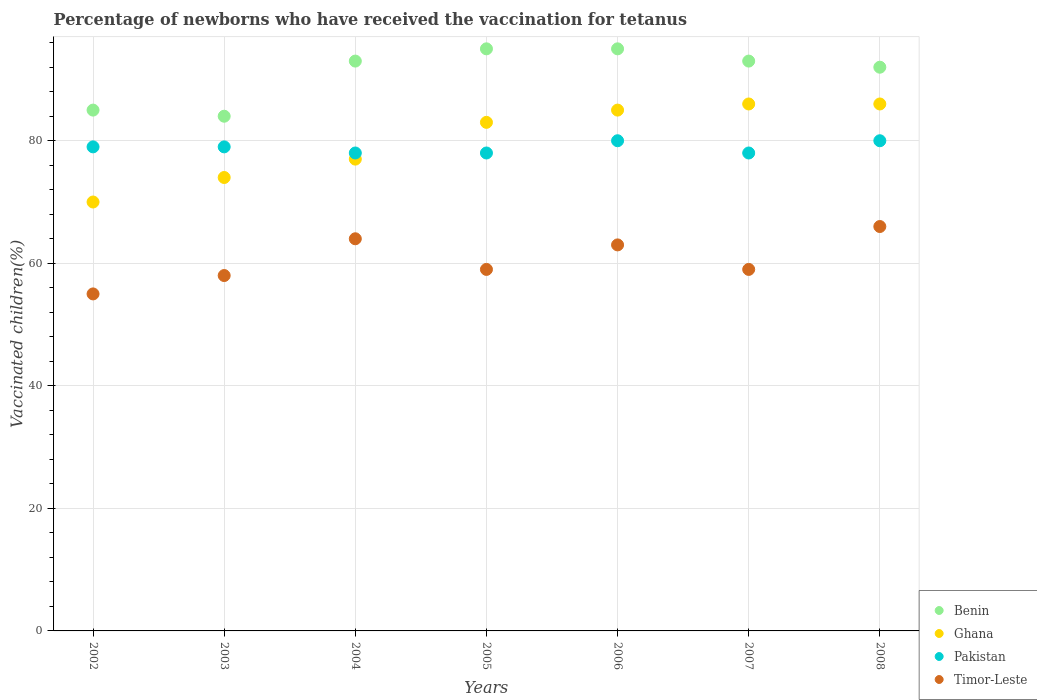How many different coloured dotlines are there?
Your answer should be very brief. 4. In which year was the percentage of vaccinated children in Timor-Leste maximum?
Provide a short and direct response. 2008. In which year was the percentage of vaccinated children in Benin minimum?
Keep it short and to the point. 2003. What is the total percentage of vaccinated children in Pakistan in the graph?
Provide a succinct answer. 552. What is the difference between the percentage of vaccinated children in Ghana in 2004 and that in 2006?
Ensure brevity in your answer.  -8. What is the difference between the percentage of vaccinated children in Timor-Leste in 2002 and the percentage of vaccinated children in Pakistan in 2007?
Your answer should be compact. -23. What is the average percentage of vaccinated children in Timor-Leste per year?
Ensure brevity in your answer.  60.57. In the year 2004, what is the difference between the percentage of vaccinated children in Benin and percentage of vaccinated children in Ghana?
Provide a succinct answer. 16. What is the ratio of the percentage of vaccinated children in Benin in 2002 to that in 2008?
Provide a succinct answer. 0.92. Is the difference between the percentage of vaccinated children in Benin in 2004 and 2007 greater than the difference between the percentage of vaccinated children in Ghana in 2004 and 2007?
Your answer should be compact. Yes. What is the difference between the highest and the lowest percentage of vaccinated children in Timor-Leste?
Ensure brevity in your answer.  11. Is the sum of the percentage of vaccinated children in Timor-Leste in 2002 and 2005 greater than the maximum percentage of vaccinated children in Benin across all years?
Your answer should be very brief. Yes. Is it the case that in every year, the sum of the percentage of vaccinated children in Benin and percentage of vaccinated children in Timor-Leste  is greater than the percentage of vaccinated children in Pakistan?
Provide a succinct answer. Yes. How many dotlines are there?
Your answer should be very brief. 4. What is the difference between two consecutive major ticks on the Y-axis?
Your response must be concise. 20. Where does the legend appear in the graph?
Provide a short and direct response. Bottom right. How many legend labels are there?
Ensure brevity in your answer.  4. How are the legend labels stacked?
Provide a succinct answer. Vertical. What is the title of the graph?
Your answer should be very brief. Percentage of newborns who have received the vaccination for tetanus. What is the label or title of the Y-axis?
Provide a short and direct response. Vaccinated children(%). What is the Vaccinated children(%) in Ghana in 2002?
Provide a succinct answer. 70. What is the Vaccinated children(%) of Pakistan in 2002?
Offer a terse response. 79. What is the Vaccinated children(%) in Benin in 2003?
Make the answer very short. 84. What is the Vaccinated children(%) of Ghana in 2003?
Make the answer very short. 74. What is the Vaccinated children(%) of Pakistan in 2003?
Offer a terse response. 79. What is the Vaccinated children(%) in Benin in 2004?
Provide a short and direct response. 93. What is the Vaccinated children(%) in Timor-Leste in 2004?
Your answer should be compact. 64. What is the Vaccinated children(%) in Pakistan in 2006?
Provide a succinct answer. 80. What is the Vaccinated children(%) of Benin in 2007?
Keep it short and to the point. 93. What is the Vaccinated children(%) of Pakistan in 2007?
Offer a very short reply. 78. What is the Vaccinated children(%) in Timor-Leste in 2007?
Make the answer very short. 59. What is the Vaccinated children(%) in Benin in 2008?
Your response must be concise. 92. Across all years, what is the maximum Vaccinated children(%) of Benin?
Give a very brief answer. 95. Across all years, what is the maximum Vaccinated children(%) of Ghana?
Offer a very short reply. 86. Across all years, what is the maximum Vaccinated children(%) in Timor-Leste?
Make the answer very short. 66. Across all years, what is the minimum Vaccinated children(%) of Timor-Leste?
Your answer should be compact. 55. What is the total Vaccinated children(%) in Benin in the graph?
Keep it short and to the point. 637. What is the total Vaccinated children(%) of Ghana in the graph?
Your answer should be very brief. 561. What is the total Vaccinated children(%) of Pakistan in the graph?
Offer a very short reply. 552. What is the total Vaccinated children(%) of Timor-Leste in the graph?
Provide a succinct answer. 424. What is the difference between the Vaccinated children(%) of Ghana in 2002 and that in 2003?
Ensure brevity in your answer.  -4. What is the difference between the Vaccinated children(%) in Pakistan in 2002 and that in 2003?
Your response must be concise. 0. What is the difference between the Vaccinated children(%) of Timor-Leste in 2002 and that in 2003?
Keep it short and to the point. -3. What is the difference between the Vaccinated children(%) of Benin in 2002 and that in 2004?
Your response must be concise. -8. What is the difference between the Vaccinated children(%) in Ghana in 2002 and that in 2004?
Offer a terse response. -7. What is the difference between the Vaccinated children(%) in Pakistan in 2002 and that in 2004?
Offer a very short reply. 1. What is the difference between the Vaccinated children(%) in Ghana in 2002 and that in 2005?
Your answer should be compact. -13. What is the difference between the Vaccinated children(%) in Pakistan in 2002 and that in 2005?
Ensure brevity in your answer.  1. What is the difference between the Vaccinated children(%) in Timor-Leste in 2002 and that in 2005?
Offer a terse response. -4. What is the difference between the Vaccinated children(%) of Benin in 2002 and that in 2006?
Your answer should be compact. -10. What is the difference between the Vaccinated children(%) of Ghana in 2002 and that in 2006?
Provide a short and direct response. -15. What is the difference between the Vaccinated children(%) of Pakistan in 2002 and that in 2006?
Provide a short and direct response. -1. What is the difference between the Vaccinated children(%) in Timor-Leste in 2002 and that in 2006?
Provide a succinct answer. -8. What is the difference between the Vaccinated children(%) of Ghana in 2002 and that in 2007?
Provide a succinct answer. -16. What is the difference between the Vaccinated children(%) of Pakistan in 2002 and that in 2007?
Give a very brief answer. 1. What is the difference between the Vaccinated children(%) of Timor-Leste in 2002 and that in 2007?
Ensure brevity in your answer.  -4. What is the difference between the Vaccinated children(%) in Pakistan in 2002 and that in 2008?
Your answer should be compact. -1. What is the difference between the Vaccinated children(%) in Timor-Leste in 2003 and that in 2005?
Offer a very short reply. -1. What is the difference between the Vaccinated children(%) in Ghana in 2003 and that in 2006?
Make the answer very short. -11. What is the difference between the Vaccinated children(%) in Pakistan in 2003 and that in 2006?
Provide a succinct answer. -1. What is the difference between the Vaccinated children(%) of Benin in 2003 and that in 2007?
Offer a very short reply. -9. What is the difference between the Vaccinated children(%) in Ghana in 2003 and that in 2007?
Make the answer very short. -12. What is the difference between the Vaccinated children(%) in Pakistan in 2003 and that in 2007?
Your answer should be compact. 1. What is the difference between the Vaccinated children(%) of Timor-Leste in 2003 and that in 2007?
Ensure brevity in your answer.  -1. What is the difference between the Vaccinated children(%) of Pakistan in 2003 and that in 2008?
Keep it short and to the point. -1. What is the difference between the Vaccinated children(%) in Ghana in 2004 and that in 2005?
Your answer should be very brief. -6. What is the difference between the Vaccinated children(%) of Ghana in 2004 and that in 2006?
Give a very brief answer. -8. What is the difference between the Vaccinated children(%) of Timor-Leste in 2004 and that in 2006?
Offer a very short reply. 1. What is the difference between the Vaccinated children(%) of Benin in 2004 and that in 2007?
Your response must be concise. 0. What is the difference between the Vaccinated children(%) in Pakistan in 2004 and that in 2007?
Offer a terse response. 0. What is the difference between the Vaccinated children(%) of Timor-Leste in 2004 and that in 2007?
Provide a short and direct response. 5. What is the difference between the Vaccinated children(%) of Benin in 2004 and that in 2008?
Your answer should be compact. 1. What is the difference between the Vaccinated children(%) of Pakistan in 2004 and that in 2008?
Provide a short and direct response. -2. What is the difference between the Vaccinated children(%) in Timor-Leste in 2004 and that in 2008?
Provide a short and direct response. -2. What is the difference between the Vaccinated children(%) of Benin in 2005 and that in 2006?
Offer a terse response. 0. What is the difference between the Vaccinated children(%) in Pakistan in 2005 and that in 2006?
Your answer should be compact. -2. What is the difference between the Vaccinated children(%) of Benin in 2005 and that in 2007?
Keep it short and to the point. 2. What is the difference between the Vaccinated children(%) in Ghana in 2005 and that in 2007?
Provide a short and direct response. -3. What is the difference between the Vaccinated children(%) of Pakistan in 2005 and that in 2007?
Keep it short and to the point. 0. What is the difference between the Vaccinated children(%) in Timor-Leste in 2005 and that in 2007?
Your answer should be compact. 0. What is the difference between the Vaccinated children(%) of Timor-Leste in 2005 and that in 2008?
Provide a short and direct response. -7. What is the difference between the Vaccinated children(%) of Benin in 2006 and that in 2007?
Your response must be concise. 2. What is the difference between the Vaccinated children(%) in Pakistan in 2006 and that in 2007?
Offer a very short reply. 2. What is the difference between the Vaccinated children(%) in Timor-Leste in 2006 and that in 2007?
Keep it short and to the point. 4. What is the difference between the Vaccinated children(%) in Benin in 2006 and that in 2008?
Your answer should be very brief. 3. What is the difference between the Vaccinated children(%) of Ghana in 2006 and that in 2008?
Your answer should be compact. -1. What is the difference between the Vaccinated children(%) of Timor-Leste in 2007 and that in 2008?
Give a very brief answer. -7. What is the difference between the Vaccinated children(%) in Benin in 2002 and the Vaccinated children(%) in Pakistan in 2003?
Your answer should be very brief. 6. What is the difference between the Vaccinated children(%) in Ghana in 2002 and the Vaccinated children(%) in Pakistan in 2003?
Your response must be concise. -9. What is the difference between the Vaccinated children(%) in Pakistan in 2002 and the Vaccinated children(%) in Timor-Leste in 2003?
Give a very brief answer. 21. What is the difference between the Vaccinated children(%) of Benin in 2002 and the Vaccinated children(%) of Pakistan in 2004?
Your answer should be very brief. 7. What is the difference between the Vaccinated children(%) in Benin in 2002 and the Vaccinated children(%) in Timor-Leste in 2004?
Your response must be concise. 21. What is the difference between the Vaccinated children(%) of Ghana in 2002 and the Vaccinated children(%) of Timor-Leste in 2004?
Your answer should be compact. 6. What is the difference between the Vaccinated children(%) in Pakistan in 2002 and the Vaccinated children(%) in Timor-Leste in 2004?
Make the answer very short. 15. What is the difference between the Vaccinated children(%) of Benin in 2002 and the Vaccinated children(%) of Ghana in 2005?
Your response must be concise. 2. What is the difference between the Vaccinated children(%) of Ghana in 2002 and the Vaccinated children(%) of Pakistan in 2005?
Make the answer very short. -8. What is the difference between the Vaccinated children(%) of Ghana in 2002 and the Vaccinated children(%) of Timor-Leste in 2005?
Provide a succinct answer. 11. What is the difference between the Vaccinated children(%) of Benin in 2002 and the Vaccinated children(%) of Ghana in 2006?
Ensure brevity in your answer.  0. What is the difference between the Vaccinated children(%) in Benin in 2002 and the Vaccinated children(%) in Pakistan in 2006?
Offer a terse response. 5. What is the difference between the Vaccinated children(%) in Benin in 2002 and the Vaccinated children(%) in Timor-Leste in 2006?
Your answer should be very brief. 22. What is the difference between the Vaccinated children(%) of Ghana in 2002 and the Vaccinated children(%) of Timor-Leste in 2006?
Your response must be concise. 7. What is the difference between the Vaccinated children(%) in Benin in 2002 and the Vaccinated children(%) in Pakistan in 2007?
Give a very brief answer. 7. What is the difference between the Vaccinated children(%) in Benin in 2002 and the Vaccinated children(%) in Timor-Leste in 2007?
Provide a short and direct response. 26. What is the difference between the Vaccinated children(%) of Ghana in 2002 and the Vaccinated children(%) of Pakistan in 2007?
Provide a succinct answer. -8. What is the difference between the Vaccinated children(%) in Ghana in 2002 and the Vaccinated children(%) in Timor-Leste in 2007?
Make the answer very short. 11. What is the difference between the Vaccinated children(%) of Pakistan in 2002 and the Vaccinated children(%) of Timor-Leste in 2007?
Keep it short and to the point. 20. What is the difference between the Vaccinated children(%) of Benin in 2002 and the Vaccinated children(%) of Ghana in 2008?
Your response must be concise. -1. What is the difference between the Vaccinated children(%) of Benin in 2002 and the Vaccinated children(%) of Pakistan in 2008?
Ensure brevity in your answer.  5. What is the difference between the Vaccinated children(%) of Pakistan in 2002 and the Vaccinated children(%) of Timor-Leste in 2008?
Provide a short and direct response. 13. What is the difference between the Vaccinated children(%) of Benin in 2003 and the Vaccinated children(%) of Timor-Leste in 2004?
Your response must be concise. 20. What is the difference between the Vaccinated children(%) in Benin in 2003 and the Vaccinated children(%) in Pakistan in 2005?
Offer a very short reply. 6. What is the difference between the Vaccinated children(%) in Benin in 2003 and the Vaccinated children(%) in Timor-Leste in 2005?
Offer a terse response. 25. What is the difference between the Vaccinated children(%) of Ghana in 2003 and the Vaccinated children(%) of Pakistan in 2005?
Your answer should be very brief. -4. What is the difference between the Vaccinated children(%) in Ghana in 2003 and the Vaccinated children(%) in Timor-Leste in 2005?
Make the answer very short. 15. What is the difference between the Vaccinated children(%) of Pakistan in 2003 and the Vaccinated children(%) of Timor-Leste in 2005?
Offer a very short reply. 20. What is the difference between the Vaccinated children(%) in Ghana in 2003 and the Vaccinated children(%) in Timor-Leste in 2006?
Make the answer very short. 11. What is the difference between the Vaccinated children(%) of Benin in 2003 and the Vaccinated children(%) of Ghana in 2007?
Your response must be concise. -2. What is the difference between the Vaccinated children(%) of Ghana in 2003 and the Vaccinated children(%) of Pakistan in 2007?
Provide a short and direct response. -4. What is the difference between the Vaccinated children(%) in Pakistan in 2003 and the Vaccinated children(%) in Timor-Leste in 2007?
Ensure brevity in your answer.  20. What is the difference between the Vaccinated children(%) in Benin in 2003 and the Vaccinated children(%) in Timor-Leste in 2008?
Make the answer very short. 18. What is the difference between the Vaccinated children(%) in Ghana in 2003 and the Vaccinated children(%) in Pakistan in 2008?
Provide a succinct answer. -6. What is the difference between the Vaccinated children(%) of Ghana in 2003 and the Vaccinated children(%) of Timor-Leste in 2008?
Your response must be concise. 8. What is the difference between the Vaccinated children(%) in Benin in 2004 and the Vaccinated children(%) in Pakistan in 2005?
Provide a succinct answer. 15. What is the difference between the Vaccinated children(%) in Benin in 2004 and the Vaccinated children(%) in Timor-Leste in 2005?
Keep it short and to the point. 34. What is the difference between the Vaccinated children(%) in Pakistan in 2004 and the Vaccinated children(%) in Timor-Leste in 2005?
Make the answer very short. 19. What is the difference between the Vaccinated children(%) in Benin in 2004 and the Vaccinated children(%) in Ghana in 2006?
Keep it short and to the point. 8. What is the difference between the Vaccinated children(%) in Benin in 2004 and the Vaccinated children(%) in Pakistan in 2006?
Ensure brevity in your answer.  13. What is the difference between the Vaccinated children(%) in Ghana in 2004 and the Vaccinated children(%) in Timor-Leste in 2006?
Provide a short and direct response. 14. What is the difference between the Vaccinated children(%) of Benin in 2004 and the Vaccinated children(%) of Ghana in 2007?
Ensure brevity in your answer.  7. What is the difference between the Vaccinated children(%) in Benin in 2004 and the Vaccinated children(%) in Pakistan in 2007?
Give a very brief answer. 15. What is the difference between the Vaccinated children(%) of Ghana in 2004 and the Vaccinated children(%) of Pakistan in 2007?
Provide a succinct answer. -1. What is the difference between the Vaccinated children(%) in Ghana in 2004 and the Vaccinated children(%) in Timor-Leste in 2007?
Offer a very short reply. 18. What is the difference between the Vaccinated children(%) in Benin in 2004 and the Vaccinated children(%) in Ghana in 2008?
Offer a very short reply. 7. What is the difference between the Vaccinated children(%) of Benin in 2004 and the Vaccinated children(%) of Pakistan in 2008?
Make the answer very short. 13. What is the difference between the Vaccinated children(%) in Benin in 2004 and the Vaccinated children(%) in Timor-Leste in 2008?
Give a very brief answer. 27. What is the difference between the Vaccinated children(%) of Ghana in 2004 and the Vaccinated children(%) of Pakistan in 2008?
Your response must be concise. -3. What is the difference between the Vaccinated children(%) in Benin in 2005 and the Vaccinated children(%) in Ghana in 2006?
Offer a terse response. 10. What is the difference between the Vaccinated children(%) of Benin in 2005 and the Vaccinated children(%) of Pakistan in 2006?
Your response must be concise. 15. What is the difference between the Vaccinated children(%) of Ghana in 2005 and the Vaccinated children(%) of Timor-Leste in 2006?
Your response must be concise. 20. What is the difference between the Vaccinated children(%) in Pakistan in 2005 and the Vaccinated children(%) in Timor-Leste in 2006?
Make the answer very short. 15. What is the difference between the Vaccinated children(%) of Benin in 2005 and the Vaccinated children(%) of Pakistan in 2007?
Keep it short and to the point. 17. What is the difference between the Vaccinated children(%) of Benin in 2005 and the Vaccinated children(%) of Timor-Leste in 2007?
Make the answer very short. 36. What is the difference between the Vaccinated children(%) in Pakistan in 2005 and the Vaccinated children(%) in Timor-Leste in 2007?
Your answer should be very brief. 19. What is the difference between the Vaccinated children(%) of Benin in 2005 and the Vaccinated children(%) of Ghana in 2008?
Offer a very short reply. 9. What is the difference between the Vaccinated children(%) of Benin in 2005 and the Vaccinated children(%) of Pakistan in 2008?
Your response must be concise. 15. What is the difference between the Vaccinated children(%) in Benin in 2005 and the Vaccinated children(%) in Timor-Leste in 2008?
Offer a very short reply. 29. What is the difference between the Vaccinated children(%) in Ghana in 2005 and the Vaccinated children(%) in Pakistan in 2008?
Your answer should be very brief. 3. What is the difference between the Vaccinated children(%) in Ghana in 2005 and the Vaccinated children(%) in Timor-Leste in 2008?
Your answer should be very brief. 17. What is the difference between the Vaccinated children(%) in Benin in 2006 and the Vaccinated children(%) in Ghana in 2007?
Provide a succinct answer. 9. What is the difference between the Vaccinated children(%) in Benin in 2006 and the Vaccinated children(%) in Pakistan in 2007?
Ensure brevity in your answer.  17. What is the difference between the Vaccinated children(%) in Pakistan in 2006 and the Vaccinated children(%) in Timor-Leste in 2007?
Offer a terse response. 21. What is the difference between the Vaccinated children(%) of Benin in 2006 and the Vaccinated children(%) of Timor-Leste in 2008?
Provide a short and direct response. 29. What is the difference between the Vaccinated children(%) in Ghana in 2006 and the Vaccinated children(%) in Timor-Leste in 2008?
Your answer should be very brief. 19. What is the difference between the Vaccinated children(%) of Pakistan in 2006 and the Vaccinated children(%) of Timor-Leste in 2008?
Make the answer very short. 14. What is the difference between the Vaccinated children(%) of Benin in 2007 and the Vaccinated children(%) of Ghana in 2008?
Make the answer very short. 7. What is the difference between the Vaccinated children(%) in Benin in 2007 and the Vaccinated children(%) in Pakistan in 2008?
Give a very brief answer. 13. What is the difference between the Vaccinated children(%) of Benin in 2007 and the Vaccinated children(%) of Timor-Leste in 2008?
Ensure brevity in your answer.  27. What is the difference between the Vaccinated children(%) of Ghana in 2007 and the Vaccinated children(%) of Pakistan in 2008?
Ensure brevity in your answer.  6. What is the difference between the Vaccinated children(%) in Pakistan in 2007 and the Vaccinated children(%) in Timor-Leste in 2008?
Offer a very short reply. 12. What is the average Vaccinated children(%) in Benin per year?
Keep it short and to the point. 91. What is the average Vaccinated children(%) in Ghana per year?
Provide a succinct answer. 80.14. What is the average Vaccinated children(%) in Pakistan per year?
Ensure brevity in your answer.  78.86. What is the average Vaccinated children(%) of Timor-Leste per year?
Make the answer very short. 60.57. In the year 2002, what is the difference between the Vaccinated children(%) of Ghana and Vaccinated children(%) of Timor-Leste?
Your answer should be very brief. 15. In the year 2002, what is the difference between the Vaccinated children(%) of Pakistan and Vaccinated children(%) of Timor-Leste?
Make the answer very short. 24. In the year 2004, what is the difference between the Vaccinated children(%) of Ghana and Vaccinated children(%) of Pakistan?
Your answer should be very brief. -1. In the year 2004, what is the difference between the Vaccinated children(%) of Ghana and Vaccinated children(%) of Timor-Leste?
Give a very brief answer. 13. In the year 2005, what is the difference between the Vaccinated children(%) of Benin and Vaccinated children(%) of Ghana?
Provide a succinct answer. 12. In the year 2005, what is the difference between the Vaccinated children(%) in Ghana and Vaccinated children(%) in Pakistan?
Provide a succinct answer. 5. In the year 2005, what is the difference between the Vaccinated children(%) in Ghana and Vaccinated children(%) in Timor-Leste?
Your answer should be compact. 24. In the year 2005, what is the difference between the Vaccinated children(%) in Pakistan and Vaccinated children(%) in Timor-Leste?
Ensure brevity in your answer.  19. In the year 2006, what is the difference between the Vaccinated children(%) of Benin and Vaccinated children(%) of Ghana?
Your answer should be very brief. 10. In the year 2006, what is the difference between the Vaccinated children(%) of Benin and Vaccinated children(%) of Pakistan?
Give a very brief answer. 15. In the year 2006, what is the difference between the Vaccinated children(%) in Benin and Vaccinated children(%) in Timor-Leste?
Offer a terse response. 32. In the year 2006, what is the difference between the Vaccinated children(%) of Pakistan and Vaccinated children(%) of Timor-Leste?
Your answer should be compact. 17. In the year 2007, what is the difference between the Vaccinated children(%) of Benin and Vaccinated children(%) of Ghana?
Your answer should be compact. 7. In the year 2007, what is the difference between the Vaccinated children(%) in Benin and Vaccinated children(%) in Timor-Leste?
Your answer should be compact. 34. In the year 2007, what is the difference between the Vaccinated children(%) in Ghana and Vaccinated children(%) in Pakistan?
Your answer should be very brief. 8. In the year 2007, what is the difference between the Vaccinated children(%) in Ghana and Vaccinated children(%) in Timor-Leste?
Ensure brevity in your answer.  27. In the year 2008, what is the difference between the Vaccinated children(%) of Benin and Vaccinated children(%) of Ghana?
Provide a succinct answer. 6. In the year 2008, what is the difference between the Vaccinated children(%) of Ghana and Vaccinated children(%) of Pakistan?
Your answer should be very brief. 6. In the year 2008, what is the difference between the Vaccinated children(%) in Pakistan and Vaccinated children(%) in Timor-Leste?
Provide a succinct answer. 14. What is the ratio of the Vaccinated children(%) of Benin in 2002 to that in 2003?
Provide a short and direct response. 1.01. What is the ratio of the Vaccinated children(%) in Ghana in 2002 to that in 2003?
Your answer should be compact. 0.95. What is the ratio of the Vaccinated children(%) of Pakistan in 2002 to that in 2003?
Offer a terse response. 1. What is the ratio of the Vaccinated children(%) in Timor-Leste in 2002 to that in 2003?
Provide a succinct answer. 0.95. What is the ratio of the Vaccinated children(%) in Benin in 2002 to that in 2004?
Provide a succinct answer. 0.91. What is the ratio of the Vaccinated children(%) in Pakistan in 2002 to that in 2004?
Give a very brief answer. 1.01. What is the ratio of the Vaccinated children(%) of Timor-Leste in 2002 to that in 2004?
Your answer should be very brief. 0.86. What is the ratio of the Vaccinated children(%) in Benin in 2002 to that in 2005?
Your answer should be very brief. 0.89. What is the ratio of the Vaccinated children(%) in Ghana in 2002 to that in 2005?
Make the answer very short. 0.84. What is the ratio of the Vaccinated children(%) of Pakistan in 2002 to that in 2005?
Keep it short and to the point. 1.01. What is the ratio of the Vaccinated children(%) of Timor-Leste in 2002 to that in 2005?
Ensure brevity in your answer.  0.93. What is the ratio of the Vaccinated children(%) of Benin in 2002 to that in 2006?
Give a very brief answer. 0.89. What is the ratio of the Vaccinated children(%) in Ghana in 2002 to that in 2006?
Provide a short and direct response. 0.82. What is the ratio of the Vaccinated children(%) in Pakistan in 2002 to that in 2006?
Provide a short and direct response. 0.99. What is the ratio of the Vaccinated children(%) in Timor-Leste in 2002 to that in 2006?
Ensure brevity in your answer.  0.87. What is the ratio of the Vaccinated children(%) in Benin in 2002 to that in 2007?
Your answer should be very brief. 0.91. What is the ratio of the Vaccinated children(%) of Ghana in 2002 to that in 2007?
Your response must be concise. 0.81. What is the ratio of the Vaccinated children(%) in Pakistan in 2002 to that in 2007?
Provide a succinct answer. 1.01. What is the ratio of the Vaccinated children(%) in Timor-Leste in 2002 to that in 2007?
Your answer should be very brief. 0.93. What is the ratio of the Vaccinated children(%) in Benin in 2002 to that in 2008?
Give a very brief answer. 0.92. What is the ratio of the Vaccinated children(%) of Ghana in 2002 to that in 2008?
Offer a very short reply. 0.81. What is the ratio of the Vaccinated children(%) in Pakistan in 2002 to that in 2008?
Offer a terse response. 0.99. What is the ratio of the Vaccinated children(%) of Benin in 2003 to that in 2004?
Offer a terse response. 0.9. What is the ratio of the Vaccinated children(%) of Ghana in 2003 to that in 2004?
Keep it short and to the point. 0.96. What is the ratio of the Vaccinated children(%) of Pakistan in 2003 to that in 2004?
Your response must be concise. 1.01. What is the ratio of the Vaccinated children(%) in Timor-Leste in 2003 to that in 2004?
Provide a short and direct response. 0.91. What is the ratio of the Vaccinated children(%) in Benin in 2003 to that in 2005?
Your answer should be very brief. 0.88. What is the ratio of the Vaccinated children(%) in Ghana in 2003 to that in 2005?
Your response must be concise. 0.89. What is the ratio of the Vaccinated children(%) of Pakistan in 2003 to that in 2005?
Keep it short and to the point. 1.01. What is the ratio of the Vaccinated children(%) in Timor-Leste in 2003 to that in 2005?
Make the answer very short. 0.98. What is the ratio of the Vaccinated children(%) of Benin in 2003 to that in 2006?
Ensure brevity in your answer.  0.88. What is the ratio of the Vaccinated children(%) of Ghana in 2003 to that in 2006?
Keep it short and to the point. 0.87. What is the ratio of the Vaccinated children(%) in Pakistan in 2003 to that in 2006?
Offer a terse response. 0.99. What is the ratio of the Vaccinated children(%) of Timor-Leste in 2003 to that in 2006?
Offer a terse response. 0.92. What is the ratio of the Vaccinated children(%) in Benin in 2003 to that in 2007?
Keep it short and to the point. 0.9. What is the ratio of the Vaccinated children(%) in Ghana in 2003 to that in 2007?
Ensure brevity in your answer.  0.86. What is the ratio of the Vaccinated children(%) of Pakistan in 2003 to that in 2007?
Give a very brief answer. 1.01. What is the ratio of the Vaccinated children(%) in Timor-Leste in 2003 to that in 2007?
Your answer should be very brief. 0.98. What is the ratio of the Vaccinated children(%) of Benin in 2003 to that in 2008?
Offer a very short reply. 0.91. What is the ratio of the Vaccinated children(%) in Ghana in 2003 to that in 2008?
Ensure brevity in your answer.  0.86. What is the ratio of the Vaccinated children(%) of Pakistan in 2003 to that in 2008?
Your answer should be very brief. 0.99. What is the ratio of the Vaccinated children(%) of Timor-Leste in 2003 to that in 2008?
Make the answer very short. 0.88. What is the ratio of the Vaccinated children(%) in Benin in 2004 to that in 2005?
Offer a terse response. 0.98. What is the ratio of the Vaccinated children(%) of Ghana in 2004 to that in 2005?
Your response must be concise. 0.93. What is the ratio of the Vaccinated children(%) in Timor-Leste in 2004 to that in 2005?
Your answer should be compact. 1.08. What is the ratio of the Vaccinated children(%) in Benin in 2004 to that in 2006?
Ensure brevity in your answer.  0.98. What is the ratio of the Vaccinated children(%) of Ghana in 2004 to that in 2006?
Make the answer very short. 0.91. What is the ratio of the Vaccinated children(%) in Pakistan in 2004 to that in 2006?
Offer a terse response. 0.97. What is the ratio of the Vaccinated children(%) of Timor-Leste in 2004 to that in 2006?
Keep it short and to the point. 1.02. What is the ratio of the Vaccinated children(%) of Ghana in 2004 to that in 2007?
Provide a succinct answer. 0.9. What is the ratio of the Vaccinated children(%) of Timor-Leste in 2004 to that in 2007?
Provide a succinct answer. 1.08. What is the ratio of the Vaccinated children(%) of Benin in 2004 to that in 2008?
Provide a short and direct response. 1.01. What is the ratio of the Vaccinated children(%) of Ghana in 2004 to that in 2008?
Keep it short and to the point. 0.9. What is the ratio of the Vaccinated children(%) in Pakistan in 2004 to that in 2008?
Your response must be concise. 0.97. What is the ratio of the Vaccinated children(%) in Timor-Leste in 2004 to that in 2008?
Offer a very short reply. 0.97. What is the ratio of the Vaccinated children(%) of Benin in 2005 to that in 2006?
Your answer should be very brief. 1. What is the ratio of the Vaccinated children(%) of Ghana in 2005 to that in 2006?
Give a very brief answer. 0.98. What is the ratio of the Vaccinated children(%) of Timor-Leste in 2005 to that in 2006?
Make the answer very short. 0.94. What is the ratio of the Vaccinated children(%) in Benin in 2005 to that in 2007?
Give a very brief answer. 1.02. What is the ratio of the Vaccinated children(%) of Ghana in 2005 to that in 2007?
Ensure brevity in your answer.  0.97. What is the ratio of the Vaccinated children(%) in Pakistan in 2005 to that in 2007?
Provide a succinct answer. 1. What is the ratio of the Vaccinated children(%) in Benin in 2005 to that in 2008?
Give a very brief answer. 1.03. What is the ratio of the Vaccinated children(%) of Ghana in 2005 to that in 2008?
Your answer should be very brief. 0.97. What is the ratio of the Vaccinated children(%) in Timor-Leste in 2005 to that in 2008?
Your answer should be compact. 0.89. What is the ratio of the Vaccinated children(%) of Benin in 2006 to that in 2007?
Keep it short and to the point. 1.02. What is the ratio of the Vaccinated children(%) in Ghana in 2006 to that in 2007?
Keep it short and to the point. 0.99. What is the ratio of the Vaccinated children(%) of Pakistan in 2006 to that in 2007?
Ensure brevity in your answer.  1.03. What is the ratio of the Vaccinated children(%) of Timor-Leste in 2006 to that in 2007?
Your answer should be compact. 1.07. What is the ratio of the Vaccinated children(%) in Benin in 2006 to that in 2008?
Provide a short and direct response. 1.03. What is the ratio of the Vaccinated children(%) of Ghana in 2006 to that in 2008?
Your answer should be compact. 0.99. What is the ratio of the Vaccinated children(%) in Pakistan in 2006 to that in 2008?
Offer a terse response. 1. What is the ratio of the Vaccinated children(%) of Timor-Leste in 2006 to that in 2008?
Ensure brevity in your answer.  0.95. What is the ratio of the Vaccinated children(%) in Benin in 2007 to that in 2008?
Your answer should be compact. 1.01. What is the ratio of the Vaccinated children(%) in Ghana in 2007 to that in 2008?
Your answer should be compact. 1. What is the ratio of the Vaccinated children(%) in Timor-Leste in 2007 to that in 2008?
Your answer should be compact. 0.89. What is the difference between the highest and the second highest Vaccinated children(%) in Benin?
Provide a short and direct response. 0. What is the difference between the highest and the second highest Vaccinated children(%) of Ghana?
Keep it short and to the point. 0. What is the difference between the highest and the second highest Vaccinated children(%) in Pakistan?
Offer a very short reply. 0. What is the difference between the highest and the lowest Vaccinated children(%) of Pakistan?
Offer a very short reply. 2. What is the difference between the highest and the lowest Vaccinated children(%) of Timor-Leste?
Offer a very short reply. 11. 